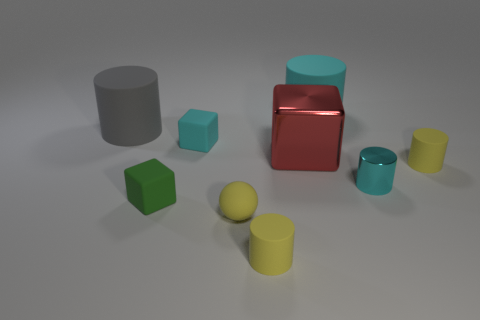How many things are both behind the small yellow sphere and right of the large gray object?
Offer a very short reply. 6. Are the gray cylinder and the small sphere made of the same material?
Provide a short and direct response. Yes. What shape is the shiny object in front of the small yellow rubber cylinder right of the big cylinder that is to the right of the small cyan cube?
Ensure brevity in your answer.  Cylinder. What is the material of the cyan thing that is in front of the gray rubber thing and to the right of the shiny cube?
Your response must be concise. Metal. What is the color of the big cylinder that is to the left of the tiny cyan thing that is on the left side of the cyan metallic cylinder to the right of the large block?
Offer a very short reply. Gray. How many purple objects are either tiny objects or tiny matte cylinders?
Give a very brief answer. 0. How many other things are there of the same size as the green thing?
Your response must be concise. 5. How many red shiny cubes are there?
Offer a very short reply. 1. Is there any other thing that has the same shape as the gray matte thing?
Make the answer very short. Yes. Is the material of the small cylinder that is in front of the yellow rubber sphere the same as the cyan object left of the cyan rubber cylinder?
Provide a short and direct response. Yes. 